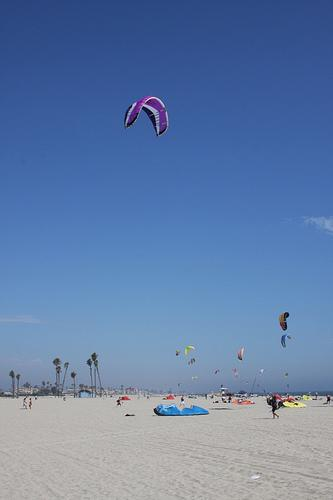What type of weather is the beach seeing today?

Choices:
A) hurricane
B) snow
C) wind
D) rain wind 